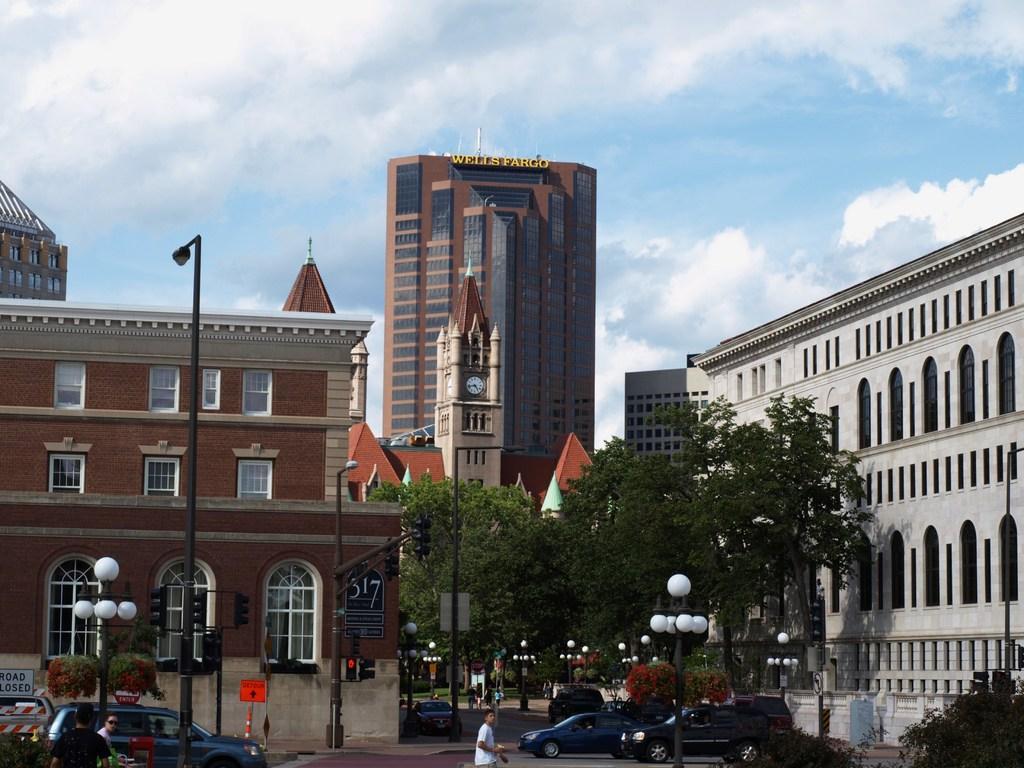Please provide a concise description of this image. At the bottom we can see vehicles and few persons on the road. In the background there are trees,plants,buildings,poles,sign board poles,windows,a clock on the tower and clouds in the sky. 